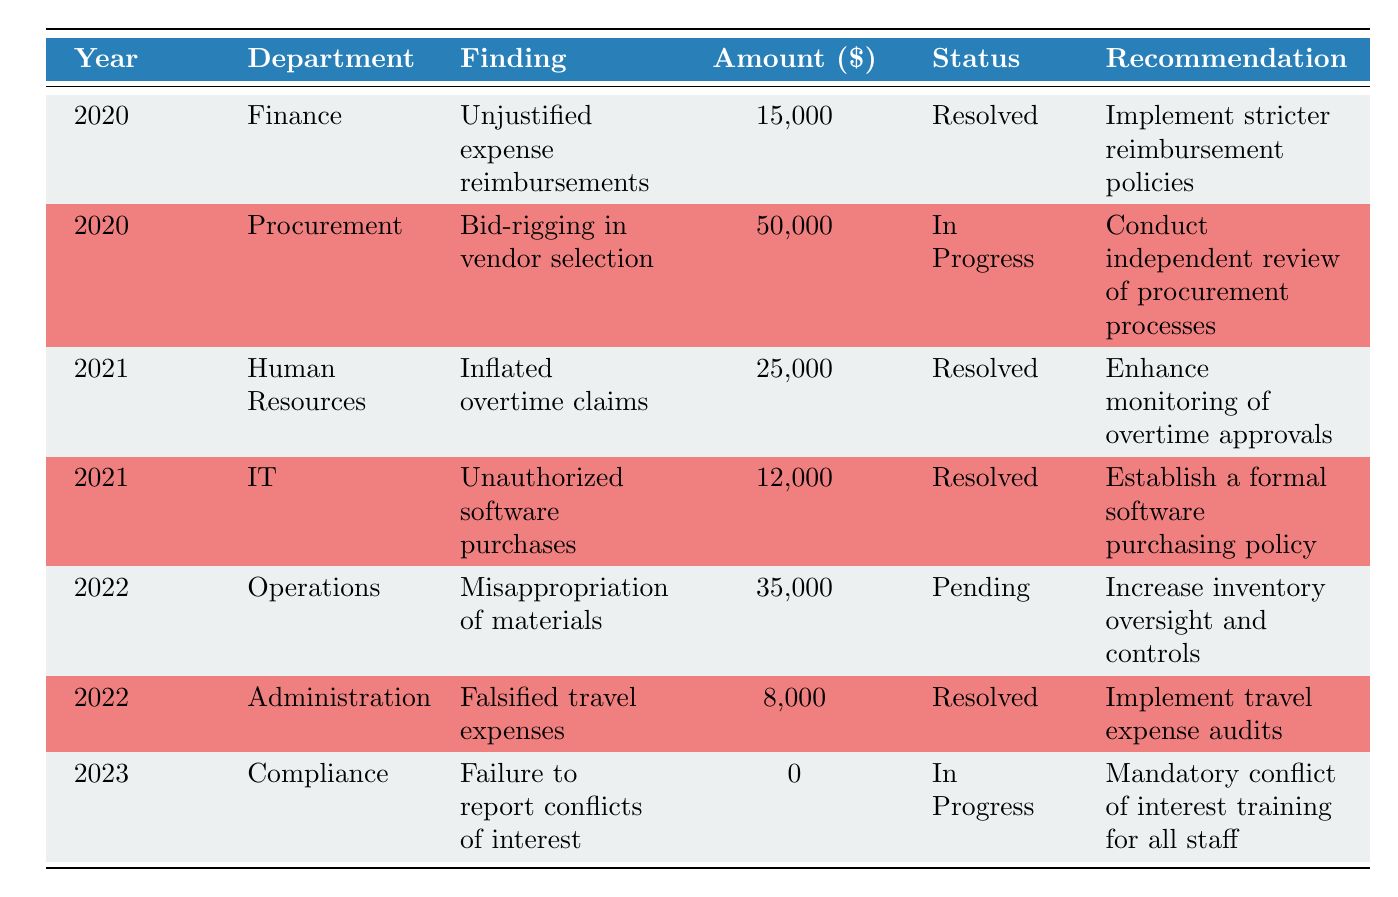What is the total amount discussed in the year 2021? In 2021, there are two findings listed: one from Human Resources for 25,000 and another from IT for 12,000. To find the total, we add these amounts: 25,000 + 12,000 = 37,000.
Answer: 37,000 Which department had the highest amount discussed for financial irregularities? The department with the highest amount discussed is Procurement in 2020, with an amount of 50,000.
Answer: Procurement What is the status of the finding related to misappropriation of materials? The finding related to misappropriation of materials from Operations in 2022 is marked as "Pending" based on the table.
Answer: Pending Is there any unresolved finding from the year 2020? The table shows that both findings from 2020 have resolved statuses. Therefore, there are no unresolved findings from that year.
Answer: No What is the average amount discussed across all years in the table? The amounts discussed are 15,000, 50,000, 25,000, 12,000, 35,000, 8,000, and 0, totaling 145,000. There are 7 entries, so the average is calculated by dividing the total by the count: 145,000 / 7 ≈ 20,714.29.
Answer: 20,714.29 What was the recommendation for the finding regarding unauthorized software purchases? The recommendation for the finding regarding unauthorized software purchases in IT in 2021 was to "Establish a formal software purchasing policy."
Answer: Establish a formal software purchasing policy How many different departments have unresolved findings? Only the following departments show unresolved findings: Procurement and Compliance. Therefore, the number of departments with unresolved findings is one.
Answer: Two 